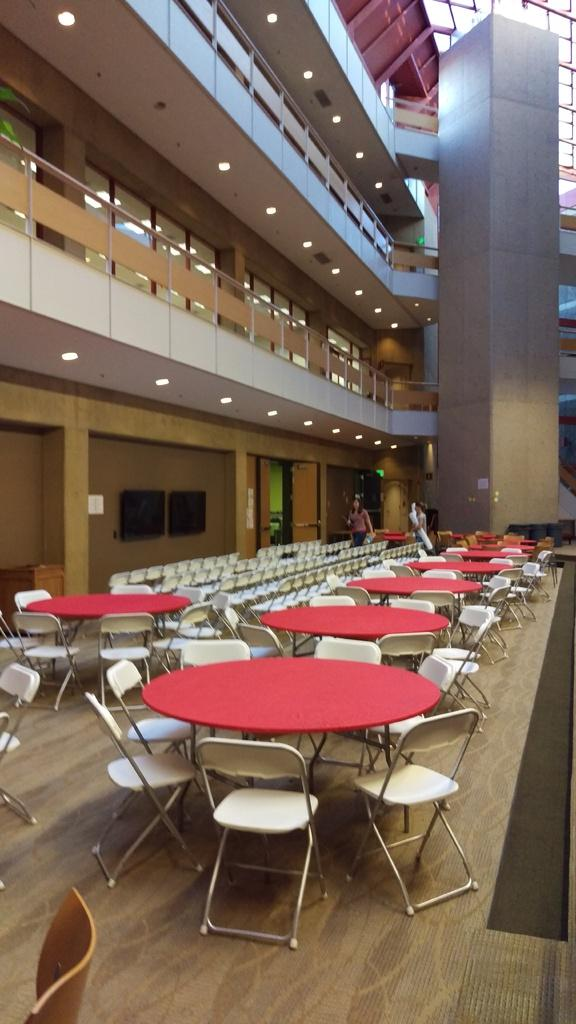What color are the chairs in the image? The chairs in the image are cream-colored. What color are the tables in the image? The tables in the image are red. What can be seen in the background of the image? The background of the image includes lights and shows the inner part of a building. What color is the wall in the image? The wall in the image is brown. How many pairs of shoes can be seen on the chairs in the image? There are no shoes visible on the chairs in the image. What type of burn can be seen on the table in the image? There is no burn present on the table in the image. 